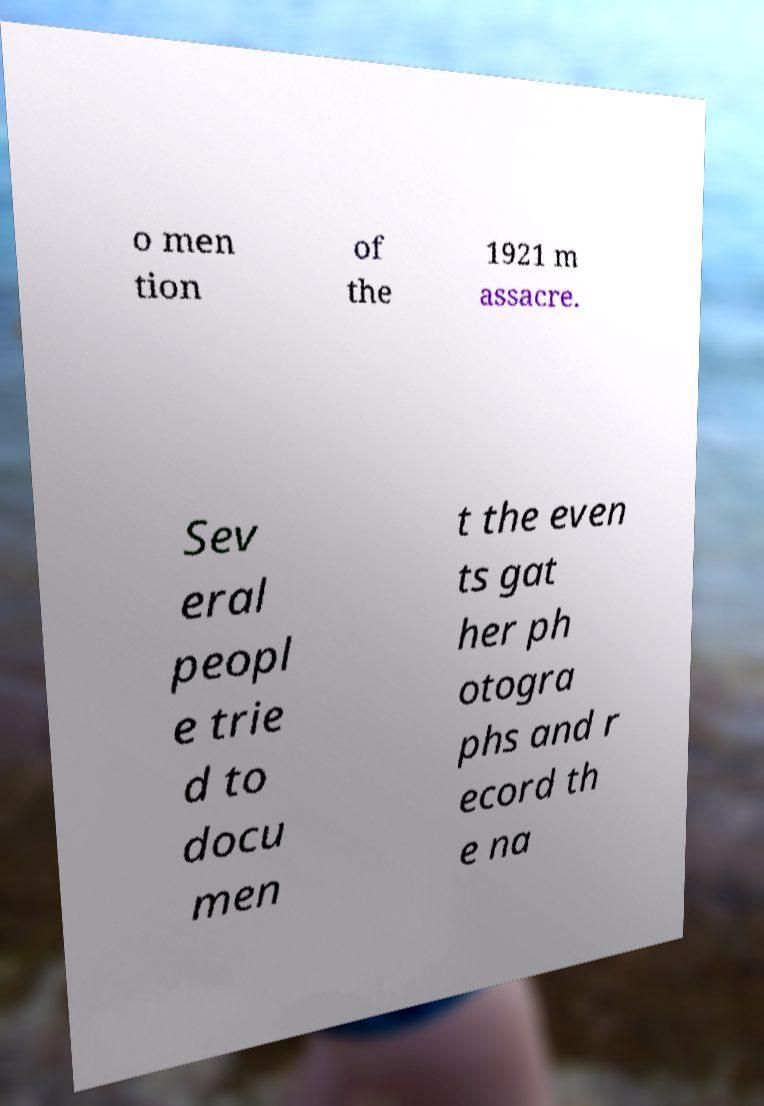I need the written content from this picture converted into text. Can you do that? o men tion of the 1921 m assacre. Sev eral peopl e trie d to docu men t the even ts gat her ph otogra phs and r ecord th e na 